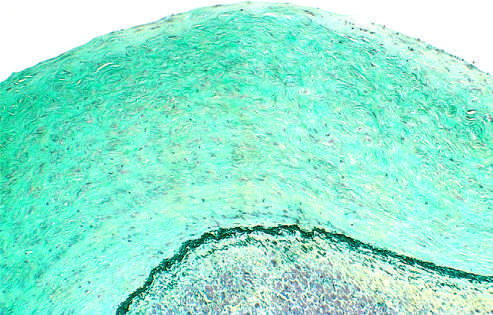does microscopic appearance of the thickened endocardium, which contains smooth muscle cells and abundant acid mucopolysaccharides blue-green in this movat stain?
Answer the question using a single word or phrase. Yes 